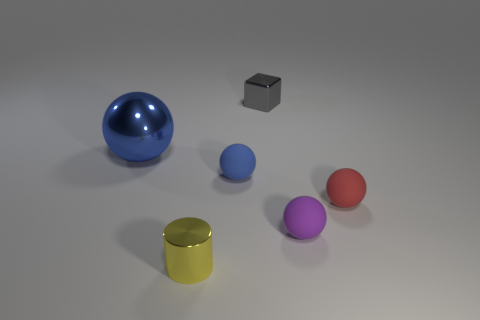Are there fewer cyan spheres than matte balls?
Offer a terse response. Yes. There is a small shiny object that is behind the sphere left of the tiny metallic cylinder; what is its color?
Offer a very short reply. Gray. What material is the blue ball that is to the right of the metallic thing that is in front of the rubber thing that is left of the tiny purple rubber sphere made of?
Ensure brevity in your answer.  Rubber. There is a rubber ball that is left of the cube; is its size the same as the small block?
Provide a short and direct response. Yes. What material is the red sphere that is right of the metallic block?
Make the answer very short. Rubber. Is the number of big gray metal objects greater than the number of gray shiny cubes?
Your answer should be very brief. No. How many things are either small metal objects that are behind the metal sphere or blue metallic things?
Your answer should be compact. 2. How many metallic things are in front of the small ball to the left of the gray block?
Make the answer very short. 1. There is a yellow cylinder in front of the small metal object right of the small sphere to the left of the tiny gray metallic block; how big is it?
Offer a very short reply. Small. There is a metallic thing in front of the big object; is its color the same as the block?
Keep it short and to the point. No. 